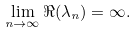Convert formula to latex. <formula><loc_0><loc_0><loc_500><loc_500>\lim _ { n \rightarrow \infty } \Re ( \lambda _ { n } ) = \infty .</formula> 